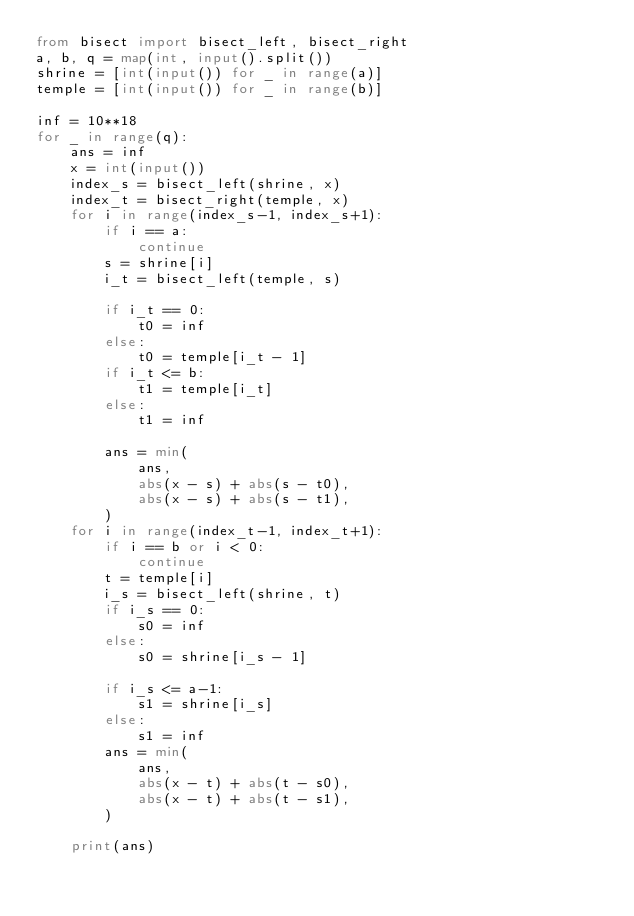Convert code to text. <code><loc_0><loc_0><loc_500><loc_500><_Python_>from bisect import bisect_left, bisect_right
a, b, q = map(int, input().split())
shrine = [int(input()) for _ in range(a)]
temple = [int(input()) for _ in range(b)]

inf = 10**18
for _ in range(q):
    ans = inf
    x = int(input())
    index_s = bisect_left(shrine, x)
    index_t = bisect_right(temple, x)
    for i in range(index_s-1, index_s+1):
        if i == a:
            continue
        s = shrine[i]
        i_t = bisect_left(temple, s)

        if i_t == 0:
            t0 = inf
        else:
            t0 = temple[i_t - 1]
        if i_t <= b:
            t1 = temple[i_t]
        else:
            t1 = inf

        ans = min(
            ans,
            abs(x - s) + abs(s - t0),
            abs(x - s) + abs(s - t1),
        )
    for i in range(index_t-1, index_t+1):
        if i == b or i < 0:
            continue
        t = temple[i]
        i_s = bisect_left(shrine, t)
        if i_s == 0:
            s0 = inf
        else:
            s0 = shrine[i_s - 1]

        if i_s <= a-1:
            s1 = shrine[i_s]
        else:
            s1 = inf
        ans = min(
            ans,
            abs(x - t) + abs(t - s0),
            abs(x - t) + abs(t - s1),
        )

    print(ans)



</code> 